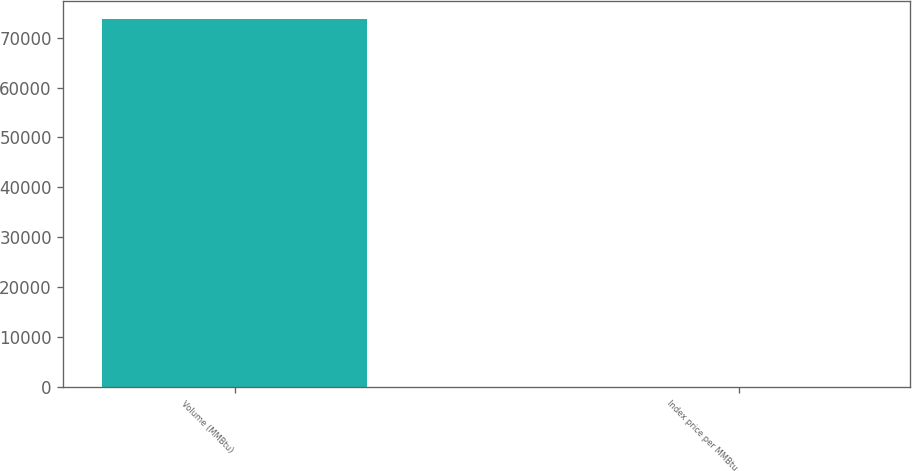Convert chart to OTSL. <chart><loc_0><loc_0><loc_500><loc_500><bar_chart><fcel>Volume (MMBtu)<fcel>Index price per MMBtu<nl><fcel>73710<fcel>4.3<nl></chart> 